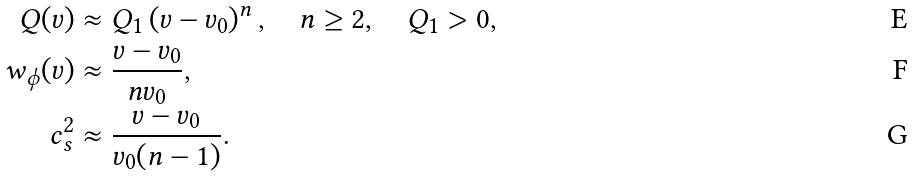<formula> <loc_0><loc_0><loc_500><loc_500>Q ( v ) & \approx Q _ { 1 } \left ( v - v _ { 0 } \right ) ^ { n } , \quad n \geq 2 , \quad Q _ { 1 } > 0 , \\ w _ { \phi } ( v ) & \approx \frac { v - v _ { 0 } } { n v _ { 0 } } , \\ c _ { s } ^ { 2 } & \approx \frac { v - v _ { 0 } } { v _ { 0 } ( n - 1 ) } .</formula> 